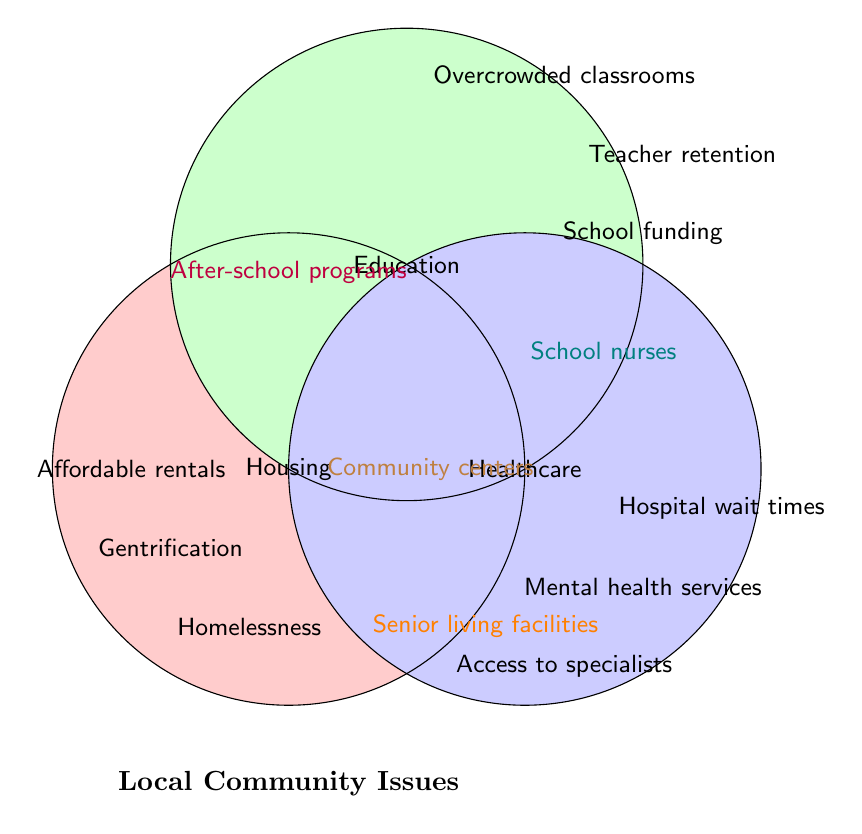What local issue is associated exclusively with Housing? The issue datasets which fall only in the "Housing" circle are considered exclusive to Housing. These are Affordable rentals, Gentrification, and Homelessness.
Answer: Affordable rentals, Gentrification, Homelessness What issues are shared between Housing and Education? The issue that falls in the overlapping area between "Housing" and "Education" is considered common to both. This issue is After-school programs.
Answer: After-school programs What color is used to represent Healthcare in the diagram? In the Venn Diagram, the circle labeled Healthcare is filled with blue color.
Answer: Blue Which issue overlaps all three categories? The central point where all three circles intersect represents issues shared by Housing, Education, and Healthcare. The issue here is Community centers.
Answer: Community centers How many issues are exclusive to Education? By counting the issues that fall only within the "Education" circle, we identify School funding, Teacher retention, and Overcrowded classrooms.
Answer: Three What issue is shared between Housing and Healthcare but not with Education? The overlapping area between the "Housing" and "Healthcare" circles, excluding the "Education" circle, contains Senior living facilities.
Answer: Senior living facilities Is access to specialists an issue related to Education? Access to specialists falls within the Healthcare circle only and does not overlap with the Education circle.
Answer: No Compare the number of issues in Housing and Healthcare. Which has more? Counting the issues exclusively within each circle: Housing (3 issues), Healthcare (3 issues). Both categories have an equal number of exclusive issues.
Answer: Equal Which category has the issue of School nurses? The area where Education and Healthcare overlap contains the issue of School nurses.
Answer: Education and Healthcare What is the number of issues related to Healthcare, either exclusively or in combination with others? Adding the number of issues in Healthcare, both exclusive and overlapping: Hospital wait times, Mental health services, Access to specialists (Healthcare exclusive), Senior living facilities (Housing & Healthcare), School nurses (Education & Healthcare), and Community centers (all three). Total is 6.
Answer: Six 